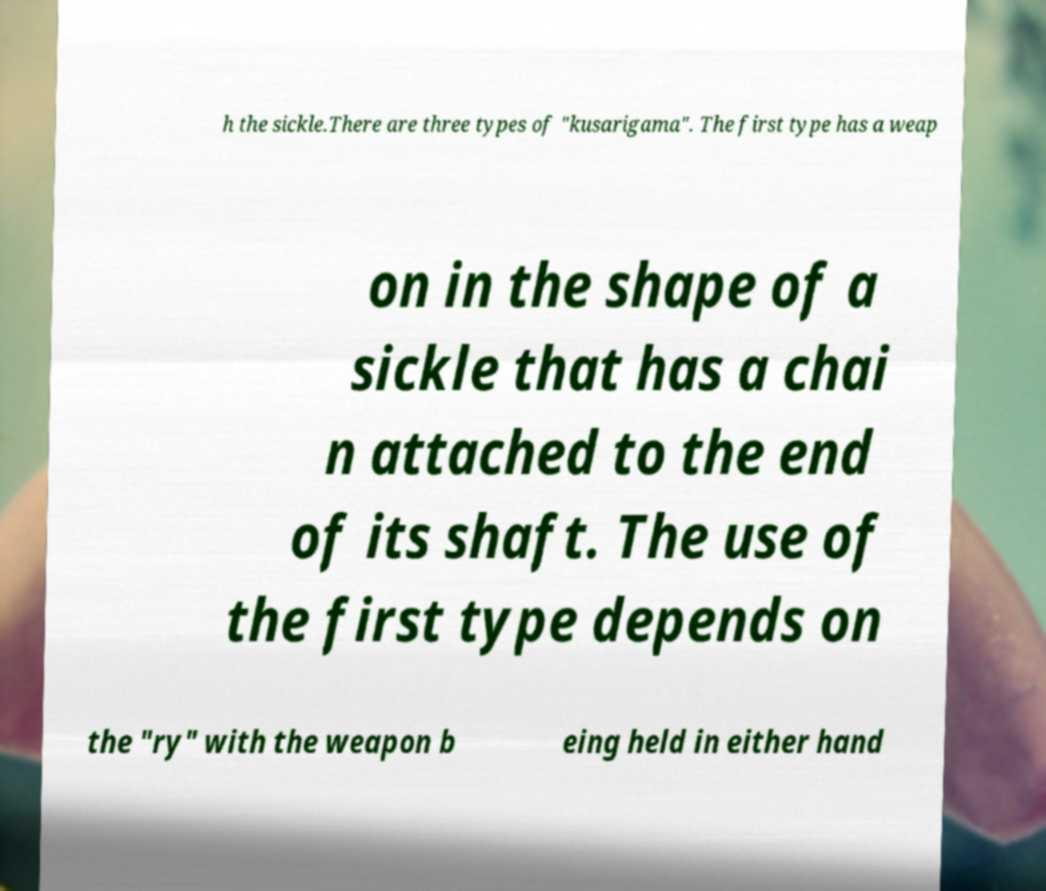Can you read and provide the text displayed in the image?This photo seems to have some interesting text. Can you extract and type it out for me? h the sickle.There are three types of "kusarigama". The first type has a weap on in the shape of a sickle that has a chai n attached to the end of its shaft. The use of the first type depends on the "ry" with the weapon b eing held in either hand 